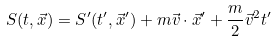Convert formula to latex. <formula><loc_0><loc_0><loc_500><loc_500>S ( t , \vec { x } ) = S ^ { \prime } ( t ^ { \prime } , \vec { x } ^ { \prime } ) + m \vec { v } \cdot \vec { x } ^ { \prime } + \frac { m } { 2 } \vec { v } ^ { 2 } t ^ { \prime }</formula> 